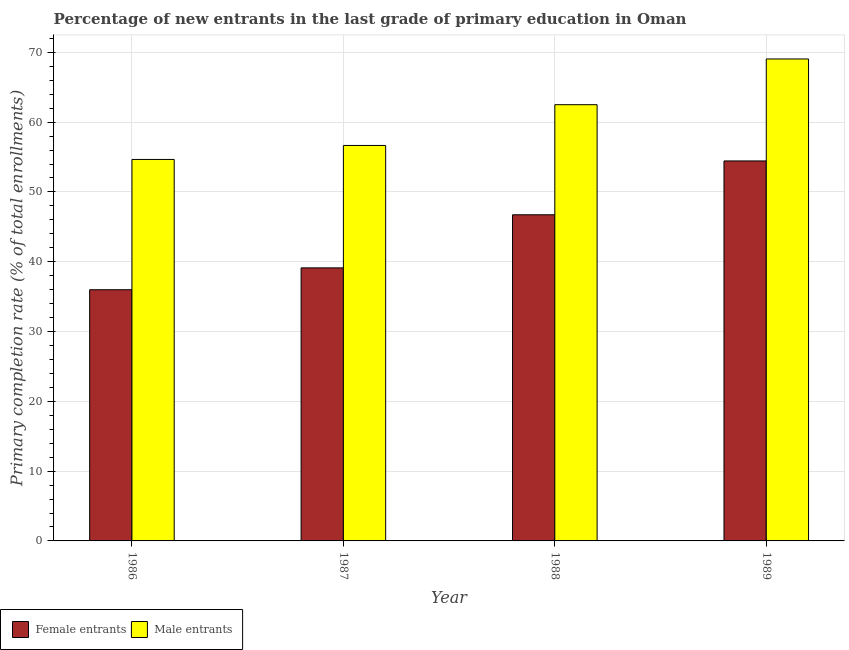How many different coloured bars are there?
Give a very brief answer. 2. How many groups of bars are there?
Provide a succinct answer. 4. Are the number of bars per tick equal to the number of legend labels?
Offer a very short reply. Yes. Are the number of bars on each tick of the X-axis equal?
Keep it short and to the point. Yes. How many bars are there on the 1st tick from the left?
Make the answer very short. 2. How many bars are there on the 4th tick from the right?
Offer a very short reply. 2. What is the label of the 2nd group of bars from the left?
Make the answer very short. 1987. In how many cases, is the number of bars for a given year not equal to the number of legend labels?
Offer a very short reply. 0. What is the primary completion rate of female entrants in 1986?
Ensure brevity in your answer.  35.99. Across all years, what is the maximum primary completion rate of female entrants?
Your answer should be very brief. 54.44. Across all years, what is the minimum primary completion rate of male entrants?
Your response must be concise. 54.65. In which year was the primary completion rate of female entrants maximum?
Provide a short and direct response. 1989. In which year was the primary completion rate of female entrants minimum?
Provide a succinct answer. 1986. What is the total primary completion rate of female entrants in the graph?
Your response must be concise. 176.27. What is the difference between the primary completion rate of female entrants in 1987 and that in 1988?
Provide a succinct answer. -7.61. What is the difference between the primary completion rate of female entrants in 1988 and the primary completion rate of male entrants in 1989?
Ensure brevity in your answer.  -7.71. What is the average primary completion rate of female entrants per year?
Your response must be concise. 44.07. In the year 1988, what is the difference between the primary completion rate of male entrants and primary completion rate of female entrants?
Provide a short and direct response. 0. In how many years, is the primary completion rate of male entrants greater than 70 %?
Provide a short and direct response. 0. What is the ratio of the primary completion rate of female entrants in 1986 to that in 1989?
Keep it short and to the point. 0.66. Is the primary completion rate of female entrants in 1987 less than that in 1989?
Offer a terse response. Yes. What is the difference between the highest and the second highest primary completion rate of male entrants?
Keep it short and to the point. 6.55. What is the difference between the highest and the lowest primary completion rate of female entrants?
Your answer should be very brief. 18.45. Is the sum of the primary completion rate of female entrants in 1987 and 1988 greater than the maximum primary completion rate of male entrants across all years?
Provide a succinct answer. Yes. What does the 1st bar from the left in 1986 represents?
Ensure brevity in your answer.  Female entrants. What does the 1st bar from the right in 1989 represents?
Your answer should be compact. Male entrants. How many bars are there?
Your answer should be compact. 8. Does the graph contain any zero values?
Your response must be concise. No. Does the graph contain grids?
Provide a succinct answer. Yes. Where does the legend appear in the graph?
Your answer should be very brief. Bottom left. How are the legend labels stacked?
Your answer should be compact. Horizontal. What is the title of the graph?
Offer a very short reply. Percentage of new entrants in the last grade of primary education in Oman. What is the label or title of the Y-axis?
Ensure brevity in your answer.  Primary completion rate (% of total enrollments). What is the Primary completion rate (% of total enrollments) of Female entrants in 1986?
Give a very brief answer. 35.99. What is the Primary completion rate (% of total enrollments) of Male entrants in 1986?
Provide a succinct answer. 54.65. What is the Primary completion rate (% of total enrollments) of Female entrants in 1987?
Your answer should be compact. 39.12. What is the Primary completion rate (% of total enrollments) in Male entrants in 1987?
Give a very brief answer. 56.66. What is the Primary completion rate (% of total enrollments) of Female entrants in 1988?
Your answer should be compact. 46.73. What is the Primary completion rate (% of total enrollments) of Male entrants in 1988?
Your answer should be very brief. 62.5. What is the Primary completion rate (% of total enrollments) of Female entrants in 1989?
Your answer should be compact. 54.44. What is the Primary completion rate (% of total enrollments) of Male entrants in 1989?
Offer a terse response. 69.05. Across all years, what is the maximum Primary completion rate (% of total enrollments) in Female entrants?
Provide a succinct answer. 54.44. Across all years, what is the maximum Primary completion rate (% of total enrollments) in Male entrants?
Your response must be concise. 69.05. Across all years, what is the minimum Primary completion rate (% of total enrollments) of Female entrants?
Your answer should be compact. 35.99. Across all years, what is the minimum Primary completion rate (% of total enrollments) in Male entrants?
Your answer should be very brief. 54.65. What is the total Primary completion rate (% of total enrollments) in Female entrants in the graph?
Ensure brevity in your answer.  176.27. What is the total Primary completion rate (% of total enrollments) in Male entrants in the graph?
Your answer should be compact. 242.86. What is the difference between the Primary completion rate (% of total enrollments) in Female entrants in 1986 and that in 1987?
Provide a short and direct response. -3.13. What is the difference between the Primary completion rate (% of total enrollments) of Male entrants in 1986 and that in 1987?
Offer a very short reply. -2. What is the difference between the Primary completion rate (% of total enrollments) of Female entrants in 1986 and that in 1988?
Provide a short and direct response. -10.74. What is the difference between the Primary completion rate (% of total enrollments) of Male entrants in 1986 and that in 1988?
Ensure brevity in your answer.  -7.84. What is the difference between the Primary completion rate (% of total enrollments) in Female entrants in 1986 and that in 1989?
Provide a short and direct response. -18.45. What is the difference between the Primary completion rate (% of total enrollments) in Male entrants in 1986 and that in 1989?
Ensure brevity in your answer.  -14.4. What is the difference between the Primary completion rate (% of total enrollments) in Female entrants in 1987 and that in 1988?
Make the answer very short. -7.61. What is the difference between the Primary completion rate (% of total enrollments) of Male entrants in 1987 and that in 1988?
Ensure brevity in your answer.  -5.84. What is the difference between the Primary completion rate (% of total enrollments) of Female entrants in 1987 and that in 1989?
Your answer should be compact. -15.32. What is the difference between the Primary completion rate (% of total enrollments) in Male entrants in 1987 and that in 1989?
Provide a succinct answer. -12.39. What is the difference between the Primary completion rate (% of total enrollments) of Female entrants in 1988 and that in 1989?
Keep it short and to the point. -7.71. What is the difference between the Primary completion rate (% of total enrollments) of Male entrants in 1988 and that in 1989?
Your answer should be very brief. -6.55. What is the difference between the Primary completion rate (% of total enrollments) of Female entrants in 1986 and the Primary completion rate (% of total enrollments) of Male entrants in 1987?
Keep it short and to the point. -20.67. What is the difference between the Primary completion rate (% of total enrollments) of Female entrants in 1986 and the Primary completion rate (% of total enrollments) of Male entrants in 1988?
Provide a short and direct response. -26.51. What is the difference between the Primary completion rate (% of total enrollments) of Female entrants in 1986 and the Primary completion rate (% of total enrollments) of Male entrants in 1989?
Your response must be concise. -33.06. What is the difference between the Primary completion rate (% of total enrollments) of Female entrants in 1987 and the Primary completion rate (% of total enrollments) of Male entrants in 1988?
Provide a succinct answer. -23.38. What is the difference between the Primary completion rate (% of total enrollments) in Female entrants in 1987 and the Primary completion rate (% of total enrollments) in Male entrants in 1989?
Your answer should be very brief. -29.93. What is the difference between the Primary completion rate (% of total enrollments) of Female entrants in 1988 and the Primary completion rate (% of total enrollments) of Male entrants in 1989?
Your response must be concise. -22.32. What is the average Primary completion rate (% of total enrollments) in Female entrants per year?
Offer a terse response. 44.07. What is the average Primary completion rate (% of total enrollments) of Male entrants per year?
Offer a terse response. 60.72. In the year 1986, what is the difference between the Primary completion rate (% of total enrollments) in Female entrants and Primary completion rate (% of total enrollments) in Male entrants?
Make the answer very short. -18.67. In the year 1987, what is the difference between the Primary completion rate (% of total enrollments) of Female entrants and Primary completion rate (% of total enrollments) of Male entrants?
Make the answer very short. -17.54. In the year 1988, what is the difference between the Primary completion rate (% of total enrollments) in Female entrants and Primary completion rate (% of total enrollments) in Male entrants?
Your answer should be very brief. -15.77. In the year 1989, what is the difference between the Primary completion rate (% of total enrollments) of Female entrants and Primary completion rate (% of total enrollments) of Male entrants?
Your response must be concise. -14.61. What is the ratio of the Primary completion rate (% of total enrollments) in Female entrants in 1986 to that in 1987?
Provide a short and direct response. 0.92. What is the ratio of the Primary completion rate (% of total enrollments) in Male entrants in 1986 to that in 1987?
Ensure brevity in your answer.  0.96. What is the ratio of the Primary completion rate (% of total enrollments) of Female entrants in 1986 to that in 1988?
Your answer should be very brief. 0.77. What is the ratio of the Primary completion rate (% of total enrollments) of Male entrants in 1986 to that in 1988?
Your answer should be very brief. 0.87. What is the ratio of the Primary completion rate (% of total enrollments) in Female entrants in 1986 to that in 1989?
Your answer should be very brief. 0.66. What is the ratio of the Primary completion rate (% of total enrollments) in Male entrants in 1986 to that in 1989?
Ensure brevity in your answer.  0.79. What is the ratio of the Primary completion rate (% of total enrollments) of Female entrants in 1987 to that in 1988?
Offer a terse response. 0.84. What is the ratio of the Primary completion rate (% of total enrollments) of Male entrants in 1987 to that in 1988?
Provide a short and direct response. 0.91. What is the ratio of the Primary completion rate (% of total enrollments) in Female entrants in 1987 to that in 1989?
Keep it short and to the point. 0.72. What is the ratio of the Primary completion rate (% of total enrollments) of Male entrants in 1987 to that in 1989?
Keep it short and to the point. 0.82. What is the ratio of the Primary completion rate (% of total enrollments) in Female entrants in 1988 to that in 1989?
Ensure brevity in your answer.  0.86. What is the ratio of the Primary completion rate (% of total enrollments) of Male entrants in 1988 to that in 1989?
Give a very brief answer. 0.91. What is the difference between the highest and the second highest Primary completion rate (% of total enrollments) in Female entrants?
Offer a terse response. 7.71. What is the difference between the highest and the second highest Primary completion rate (% of total enrollments) in Male entrants?
Your response must be concise. 6.55. What is the difference between the highest and the lowest Primary completion rate (% of total enrollments) of Female entrants?
Your response must be concise. 18.45. What is the difference between the highest and the lowest Primary completion rate (% of total enrollments) in Male entrants?
Your answer should be compact. 14.4. 